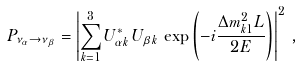<formula> <loc_0><loc_0><loc_500><loc_500>P _ { \nu _ { \alpha } \to \nu _ { \beta } } = \left | \sum _ { k = 1 } ^ { 3 } U _ { { \alpha } k } ^ { * } \, U _ { { \beta } k } \, \exp \left ( - i \frac { \Delta { m } ^ { 2 } _ { k 1 } L } { 2 E } \right ) \right | ^ { 2 } \, ,</formula> 